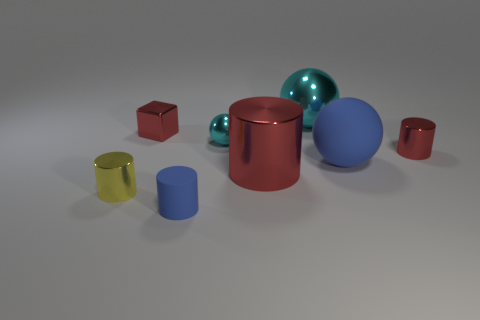Subtract all large blue spheres. How many spheres are left? 2 Subtract all spheres. How many objects are left? 5 Add 2 tiny yellow objects. How many objects exist? 10 Subtract all cyan balls. How many balls are left? 1 Subtract 0 blue blocks. How many objects are left? 8 Subtract 1 spheres. How many spheres are left? 2 Subtract all cyan blocks. Subtract all yellow cylinders. How many blocks are left? 1 Subtract all yellow cubes. How many cyan balls are left? 2 Subtract all small blocks. Subtract all metallic spheres. How many objects are left? 5 Add 8 tiny blue rubber cylinders. How many tiny blue rubber cylinders are left? 9 